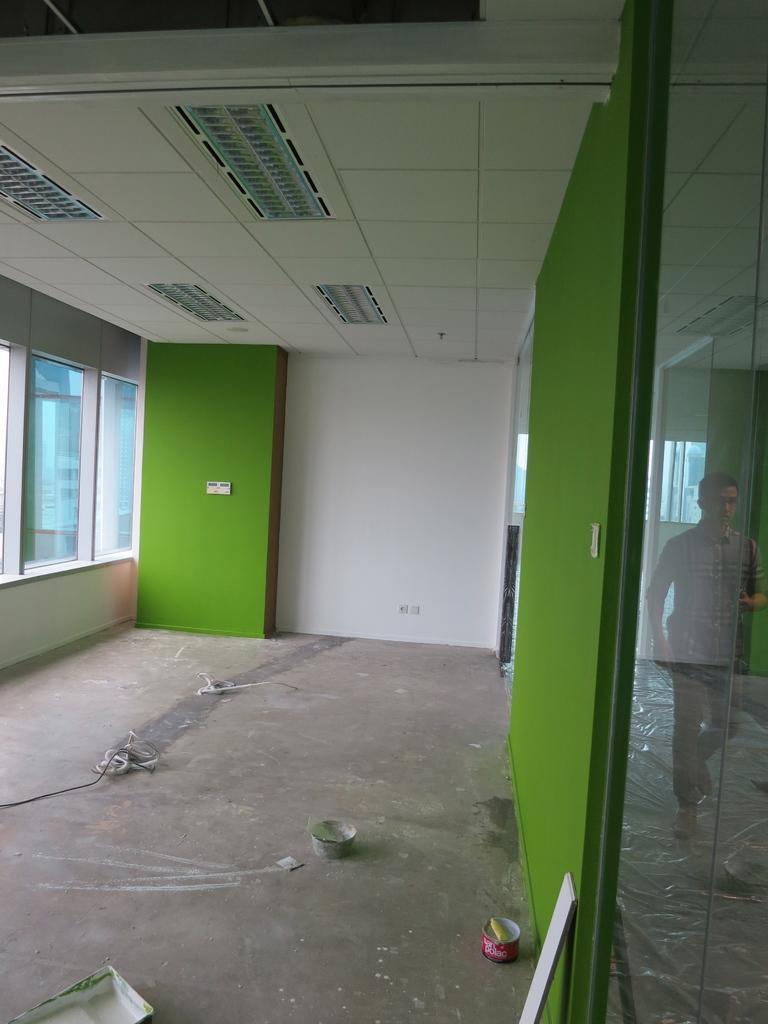Please provide a concise description of this image. In this image, we can see the ground with some objects. We can see the roof with some lights. We can also see the wall with some objects and glass windows. We can also see some glass on the right with the reflection of a person, the ground and the roof. 